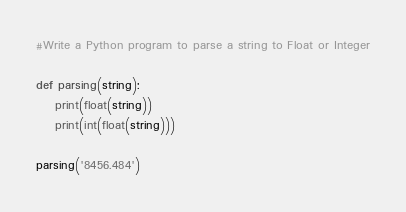Convert code to text. <code><loc_0><loc_0><loc_500><loc_500><_Python_>#Write a Python program to parse a string to Float or Integer

def parsing(string):
    print(float(string))
    print(int(float(string)))

parsing('8456.484')</code> 